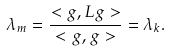<formula> <loc_0><loc_0><loc_500><loc_500>\lambda _ { m } = \frac { < g , L g > } { < g , g > } = \lambda _ { k } .</formula> 